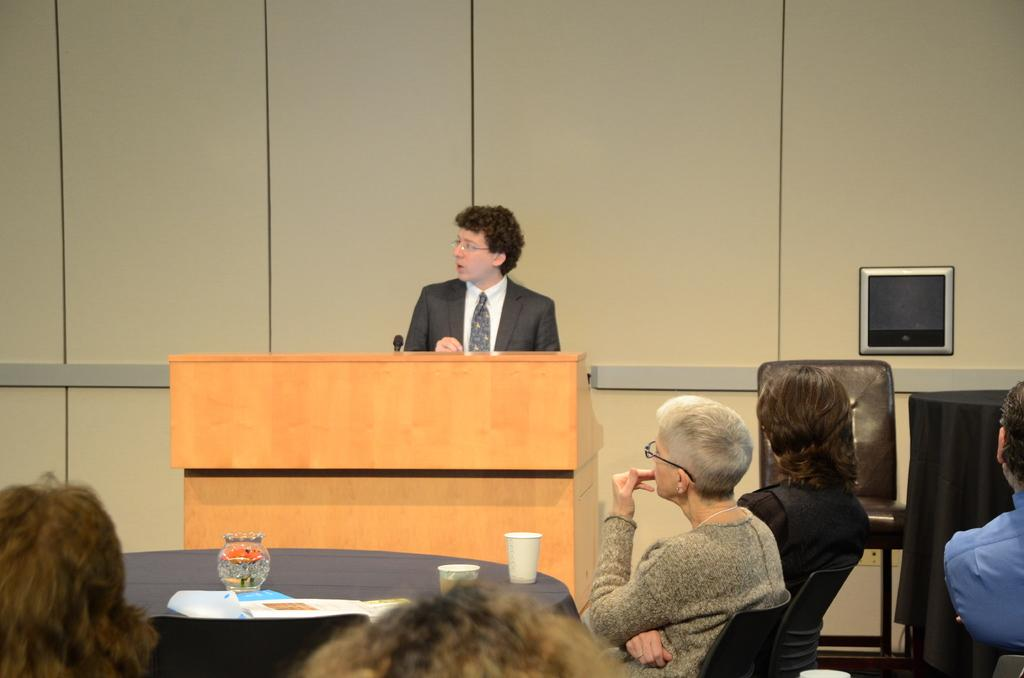What are the people in the image doing? The people in the image are sitting on chairs. What is in front of the chairs? There is a table in front of the chairs. What can be seen on the table? There are cups on the table. What is the man near the podium doing? The man is standing near a podium. What type of texture can be seen on the bottle in the image? There is no bottle present in the image. How does the kettle contribute to the atmosphere in the image? There is no kettle present in the image. 